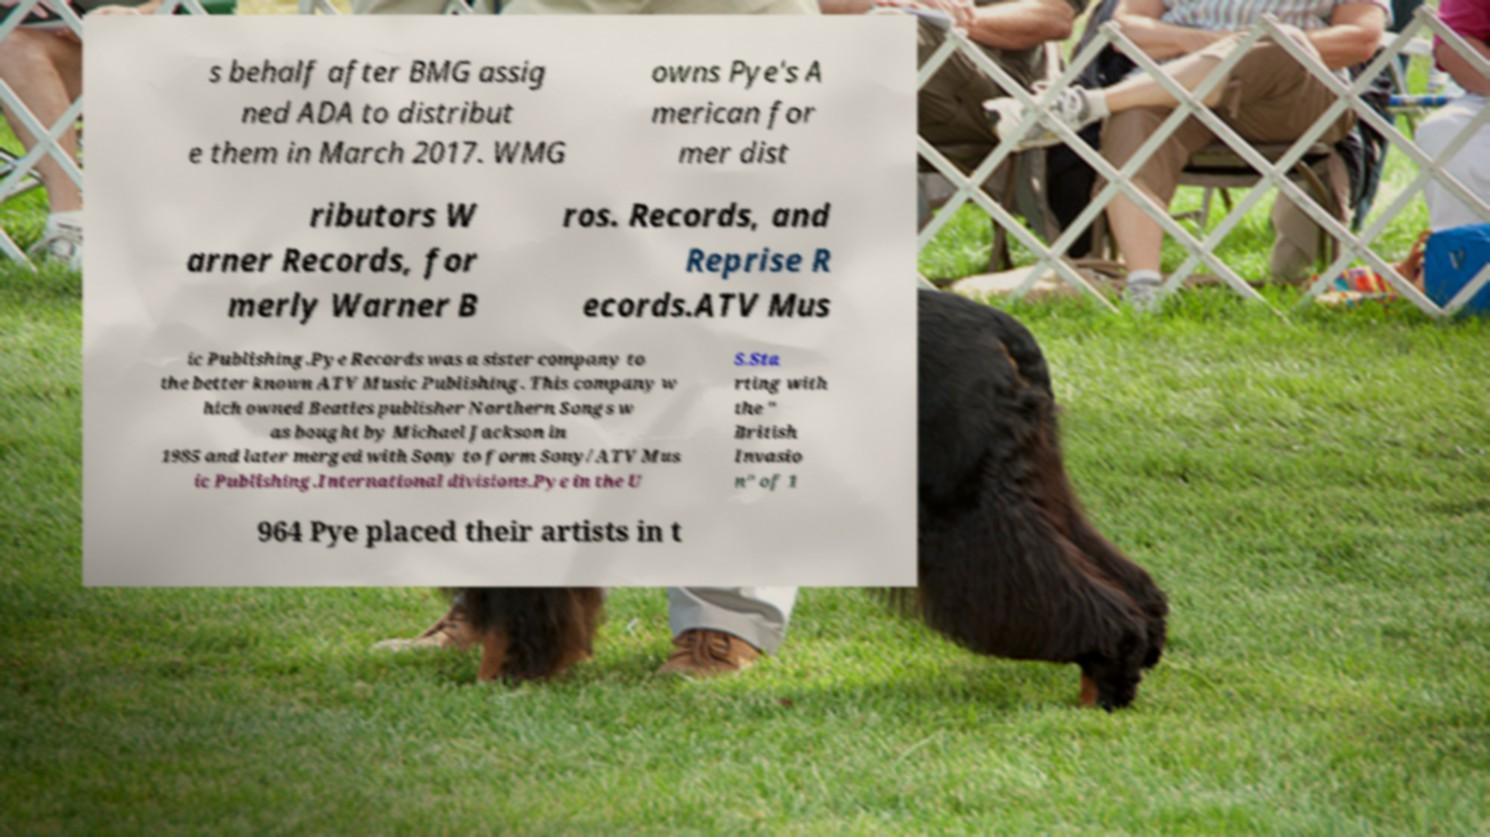There's text embedded in this image that I need extracted. Can you transcribe it verbatim? s behalf after BMG assig ned ADA to distribut e them in March 2017. WMG owns Pye's A merican for mer dist ributors W arner Records, for merly Warner B ros. Records, and Reprise R ecords.ATV Mus ic Publishing.Pye Records was a sister company to the better known ATV Music Publishing. This company w hich owned Beatles publisher Northern Songs w as bought by Michael Jackson in 1985 and later merged with Sony to form Sony/ATV Mus ic Publishing.International divisions.Pye in the U S.Sta rting with the " British Invasio n" of 1 964 Pye placed their artists in t 